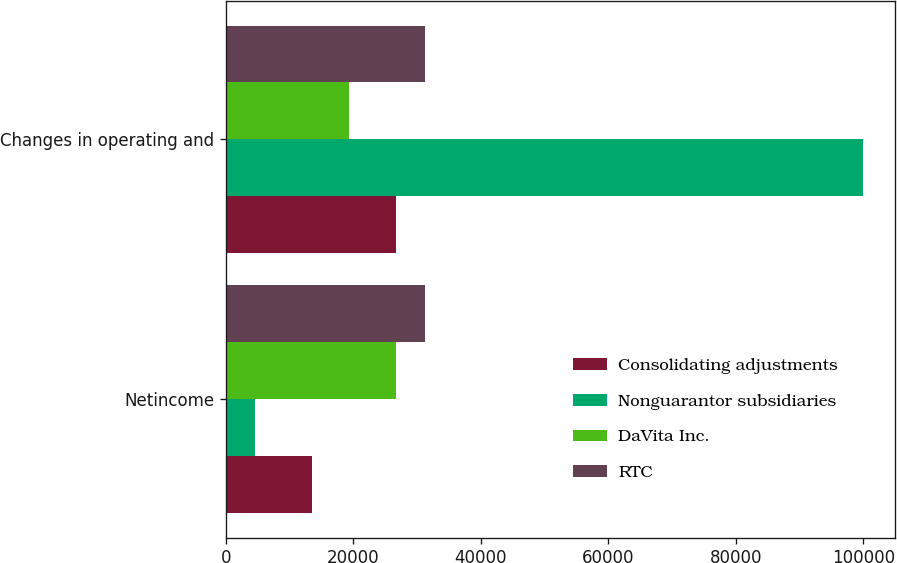Convert chart. <chart><loc_0><loc_0><loc_500><loc_500><stacked_bar_chart><ecel><fcel>Netincome<fcel>Changes in operating and<nl><fcel>Consolidating adjustments<fcel>13485<fcel>26687<nl><fcel>Nonguarantor subsidiaries<fcel>4570<fcel>99917<nl><fcel>DaVita Inc.<fcel>26687<fcel>19390<nl><fcel>RTC<fcel>31257<fcel>31257<nl></chart> 